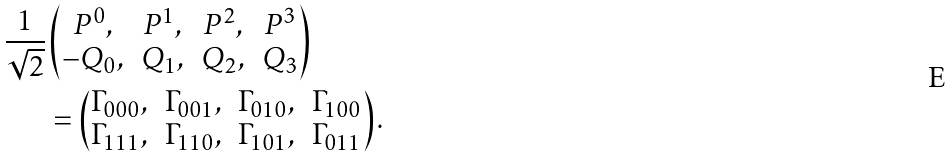Convert formula to latex. <formula><loc_0><loc_0><loc_500><loc_500>\frac { 1 } { \sqrt { 2 } } & \begin{pmatrix} P ^ { 0 } , & P ^ { 1 } , & P ^ { 2 } , & P ^ { 3 } \\ - Q _ { 0 } , & Q _ { 1 } , & Q _ { 2 } , & Q _ { 3 } \end{pmatrix} \\ & = \begin{pmatrix} \Gamma _ { 0 0 0 } , & \Gamma _ { 0 0 1 } , & \Gamma _ { 0 1 0 } , & \Gamma _ { 1 0 0 } \\ \Gamma _ { 1 1 1 } , & \Gamma _ { 1 1 0 } , & \Gamma _ { 1 0 1 } , & \Gamma _ { 0 1 1 } \end{pmatrix} .</formula> 